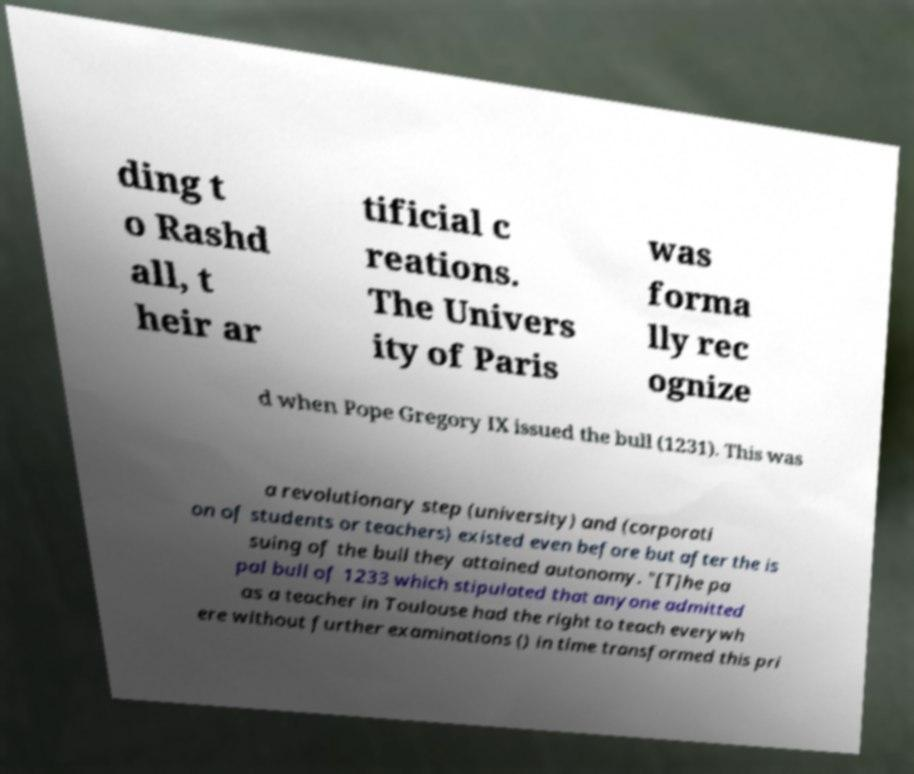Could you extract and type out the text from this image? ding t o Rashd all, t heir ar tificial c reations. The Univers ity of Paris was forma lly rec ognize d when Pope Gregory IX issued the bull (1231). This was a revolutionary step (university) and (corporati on of students or teachers) existed even before but after the is suing of the bull they attained autonomy. "[T]he pa pal bull of 1233 which stipulated that anyone admitted as a teacher in Toulouse had the right to teach everywh ere without further examinations () in time transformed this pri 